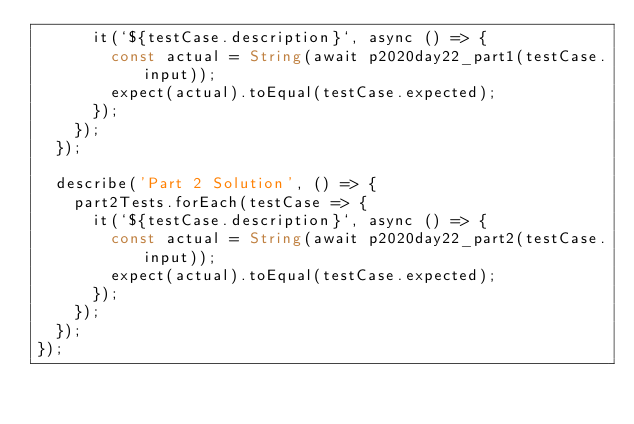<code> <loc_0><loc_0><loc_500><loc_500><_TypeScript_>      it(`${testCase.description}`, async () => {
        const actual = String(await p2020day22_part1(testCase.input));
        expect(actual).toEqual(testCase.expected);
      });
    });
  });

  describe('Part 2 Solution', () => {
    part2Tests.forEach(testCase => {
      it(`${testCase.description}`, async () => {
        const actual = String(await p2020day22_part2(testCase.input));
        expect(actual).toEqual(testCase.expected);
      });
    });
  });
});
</code> 